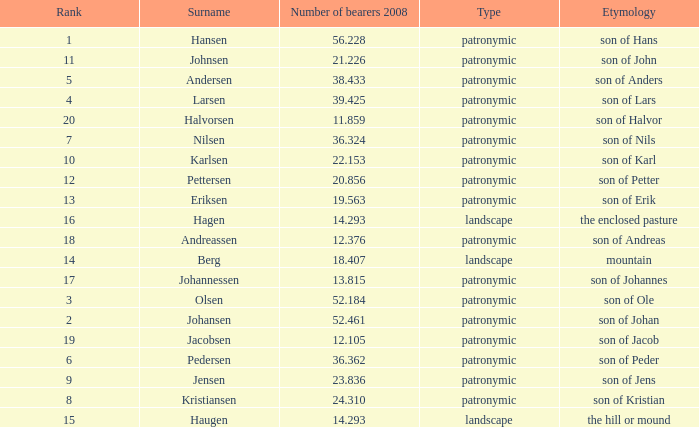What is the highest Number of Bearers 2008, when Surname is Hansen, and when Rank is less than 1? None. 